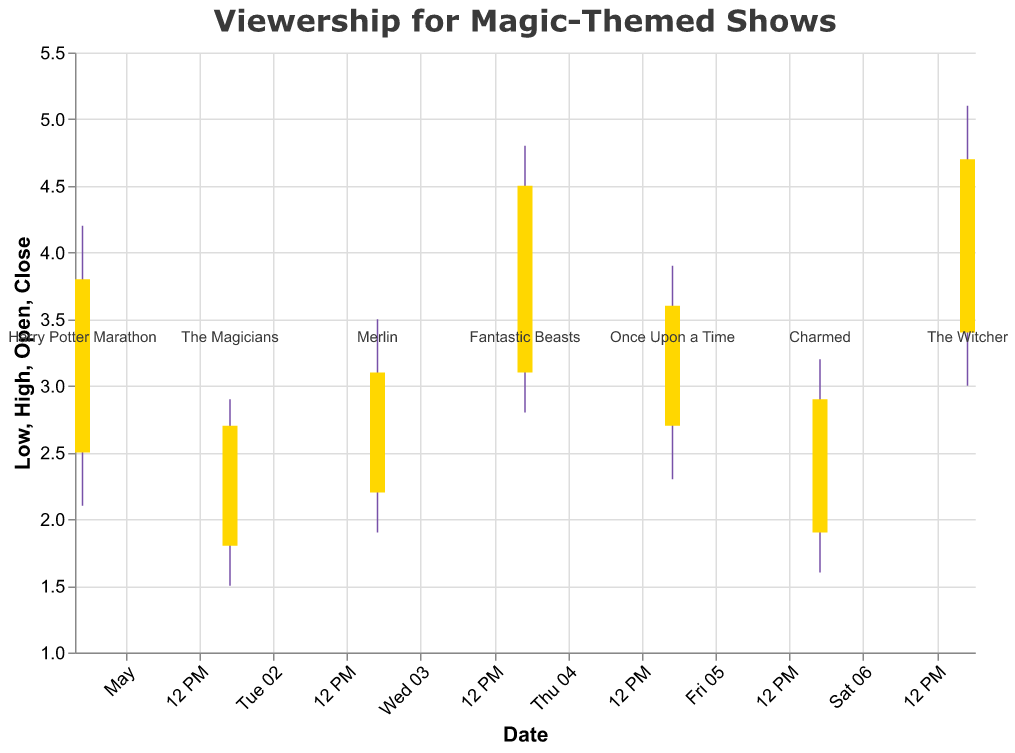Which show had the highest peak viewership? The highest peak viewership is represented by the highest value on the "High" data points. Looking at the chart, "The Witcher" had the highest peak viewership at 5.1.
Answer: The Witcher What is the average Open viewership across all shows? To find this, sum the Open values for all shows and divide by the number of shows. The sum of Open values is 2.5 + 1.8 + 2.2 + 3.1 + 2.7 + 1.9 + 3.4 = 17.6. There are 7 shows, so the average is 17.6 / 7 ≈ 2.51.
Answer: 2.51 Which show had the largest range between its Low and High viewership on a single day? The range is calculated by subtracting the Low value from the High value for each show. The show with the largest range between Low and High viewership is "The Witcher" with a range of 5.1 - 3.0 = 2.1.
Answer: The Witcher On which date did "Fantastic Beasts" have its viewership statistics recorded? From the chart, "Fantastic Beasts" is recorded on 2023-05-04.
Answer: 2023-05-04 Which show had its Close viewership higher than its Open viewership on May 3rd? The show on May 3rd is "Merlin". Its Close viewership (3.1) is higher than its Open viewership (2.2).
Answer: Merlin How many shows had their Close viewership lower than their Open viewership? By scanning through the chart, only one show had its Close viewership lower than its Open viewership: "The Magicians".
Answer: 1 What is the difference between the highest and lowest Close viewership across all shows? The highest Close viewership is 4.7 (The Witcher) and the lowest is 2.7 (The Magicians). The difference is 4.7 - 2.7 = 2.0.
Answer: 2.0 On which date did the show with the lowest Open viewership air? The lowest Open viewership is for "The Magicians" with an Open value of 1.8, recorded on 2023-05-02.
Answer: 2023-05-02 Which show had the smallest difference between its Open and Close viewership values? The difference between Open and Close for each show needs to be calculated: "Harry Potter Marathon" (1.3), "The Magicians" (0.9), "Merlin" (0.9), "Fantastic Beasts" (1.4), "Once Upon a Time" (0.9), "Charmed" (1.0), "The Witcher" (1.3). "The Magicians", "Merlin", and "Once Upon a Time" all share the smallest difference of 0.9
Answer: The Magicians, Merlin, and Once Upon a Time What is the median Close viewership value for the shows? The median is the middle value in an ordered list. Ordering the Close values (2.7, 2.9, 3.1, 3.6, 3.8, 4.5, 4.7), the middle value is 3.6.
Answer: 3.6 